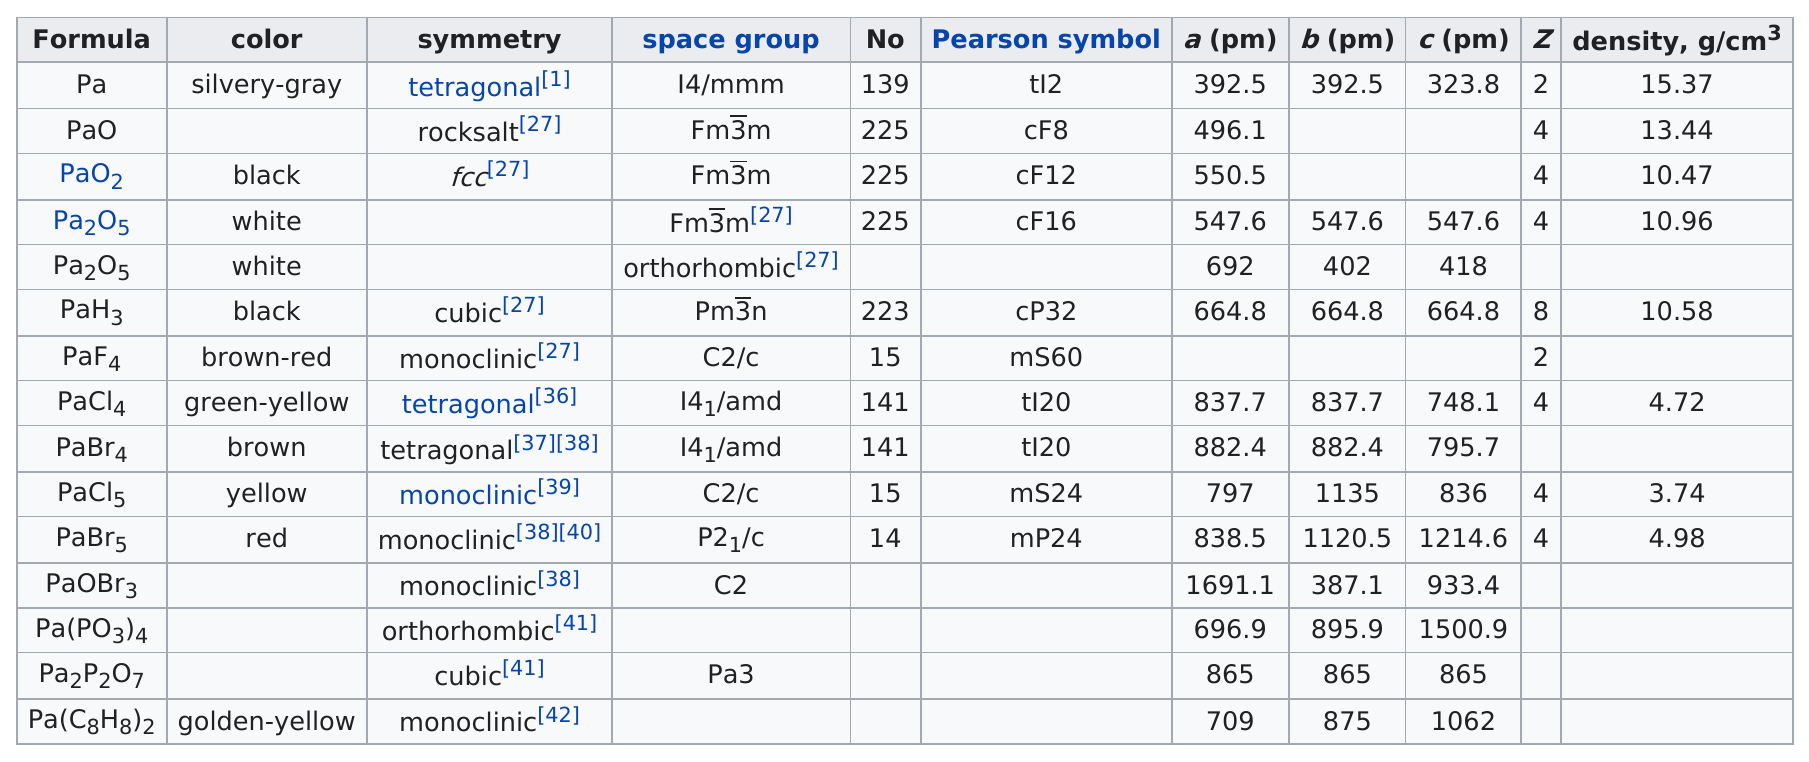Give some essential details in this illustration. The formula Pa2O5 does not have an associated symmetry type. The Pearson symbol for the formula with the lightest density is PaCl5. There are three compounds that are some shade of yellow in color. The formula with a density of at least 15 g/cm3 is (insert formula here). Of the compounds that have a color of white, there are two. 